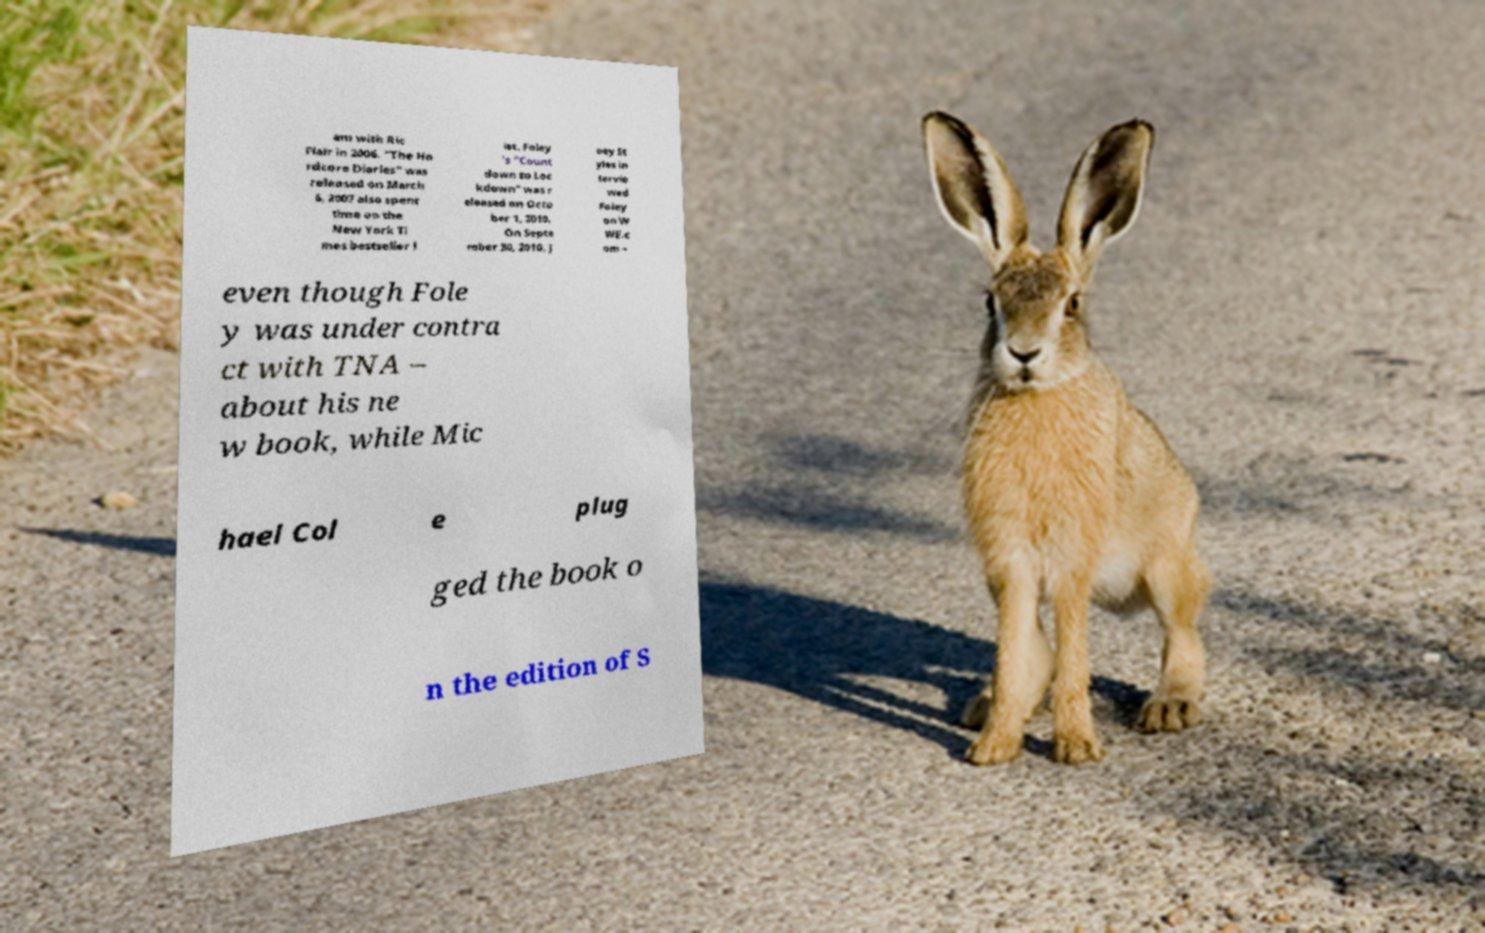For documentation purposes, I need the text within this image transcribed. Could you provide that? am with Ric Flair in 2006. "The Ha rdcore Diaries" was released on March 6, 2007 also spent time on the New York Ti mes bestseller l ist. Foley 's "Count down to Loc kdown" was r eleased on Octo ber 1, 2010. On Septe mber 30, 2010, J oey St yles in tervie wed Foley on W WE.c om – even though Fole y was under contra ct with TNA – about his ne w book, while Mic hael Col e plug ged the book o n the edition of S 